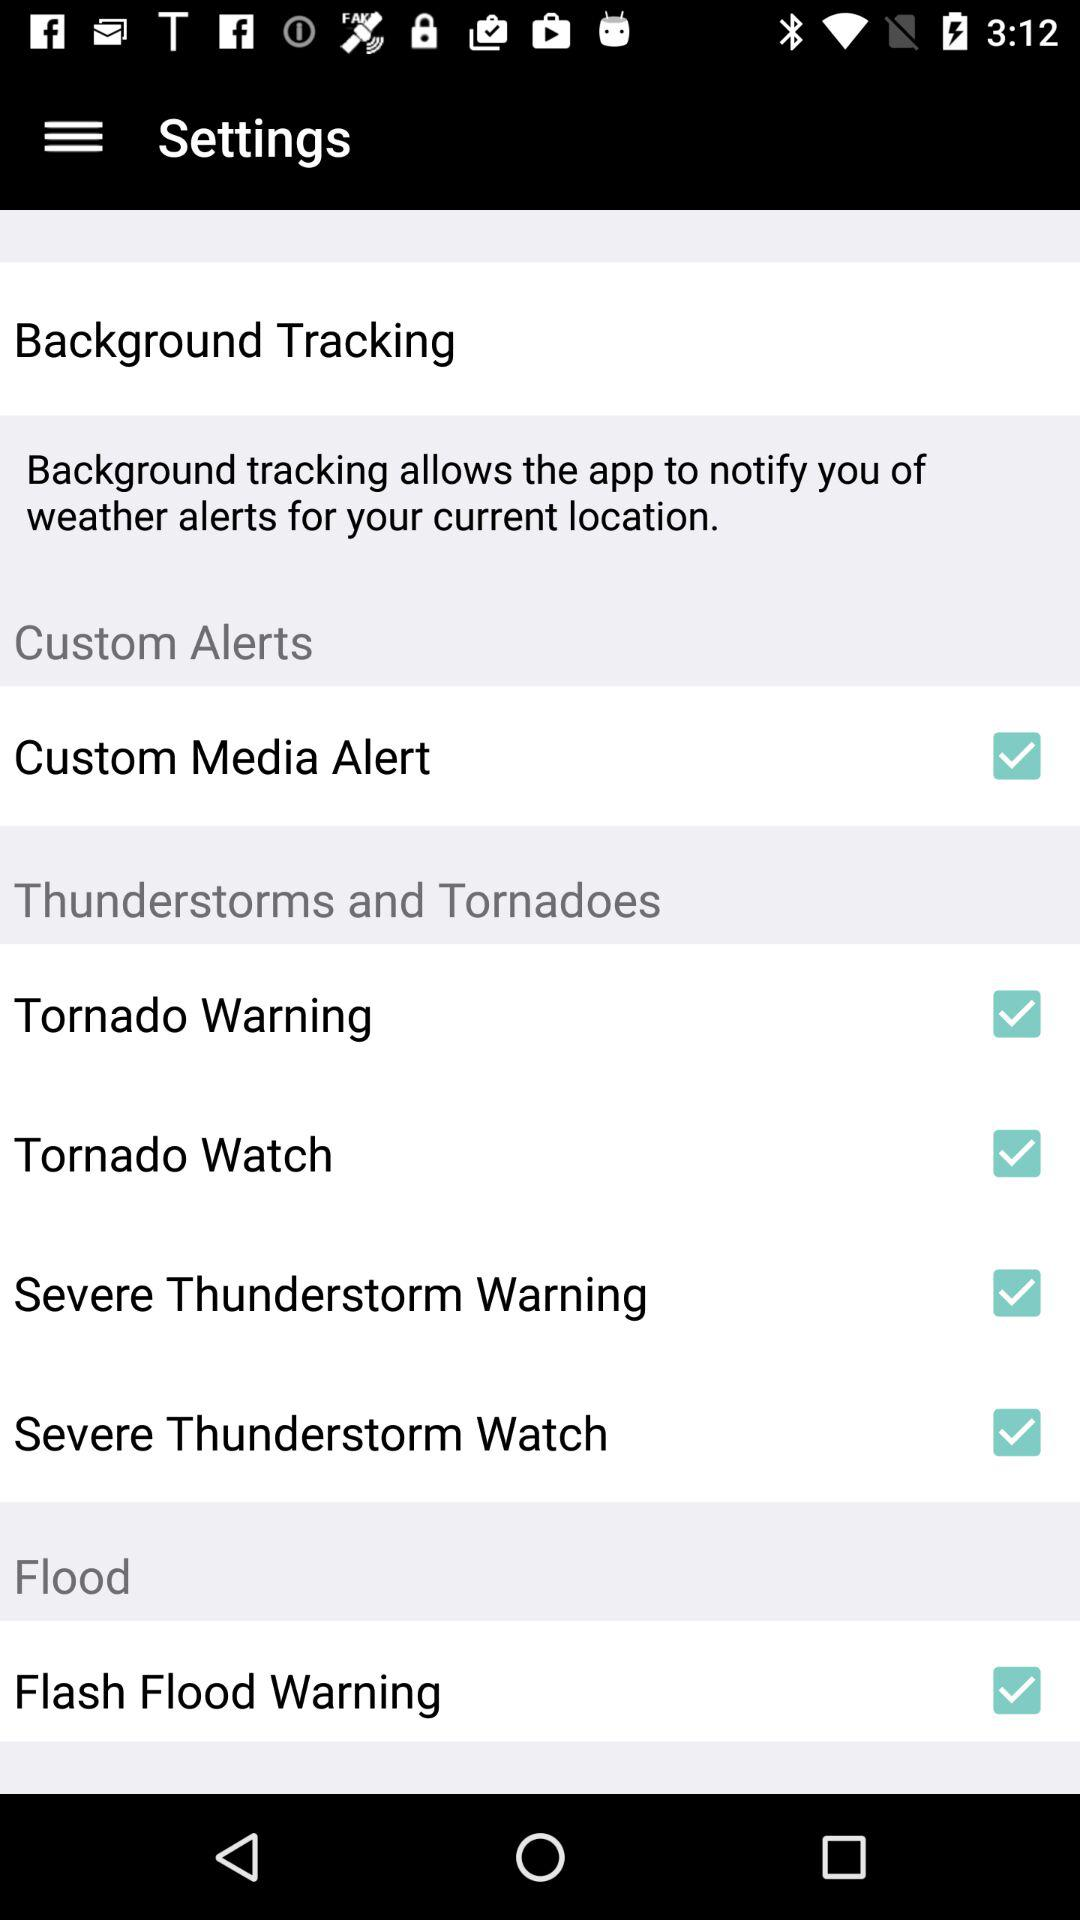Which settings are enabled under the "Thunderstorms and Tornadoes" setting panel? The settings that are enabled under the "Thunderstorms and Tornadoes" setting panel are "Tornado Warning", "Tornado Watch", "Severe Thunderstorm Warning" and "Severe Thunderstorm Watch". 